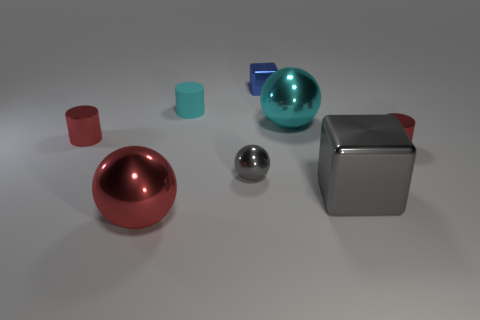What is the material of the thing that is the same color as the rubber cylinder?
Provide a short and direct response. Metal. Is the big metallic block the same color as the small ball?
Your answer should be very brief. Yes. The tiny blue object that is the same material as the large red sphere is what shape?
Your response must be concise. Cube. What material is the big ball to the left of the big metal sphere that is behind the tiny shiny cylinder that is right of the large red object?
Your response must be concise. Metal. How many objects are either cylinders that are behind the large cyan thing or large cyan rubber blocks?
Offer a terse response. 1. How many other objects are the same shape as the tiny gray metal object?
Your answer should be very brief. 2. Is the number of spheres on the left side of the cyan cylinder greater than the number of green cylinders?
Provide a succinct answer. Yes. What is the size of the cyan shiny thing that is the same shape as the large red shiny object?
Ensure brevity in your answer.  Large. Is there anything else that is made of the same material as the small cyan cylinder?
Your response must be concise. No. What shape is the blue metal object?
Give a very brief answer. Cube. 